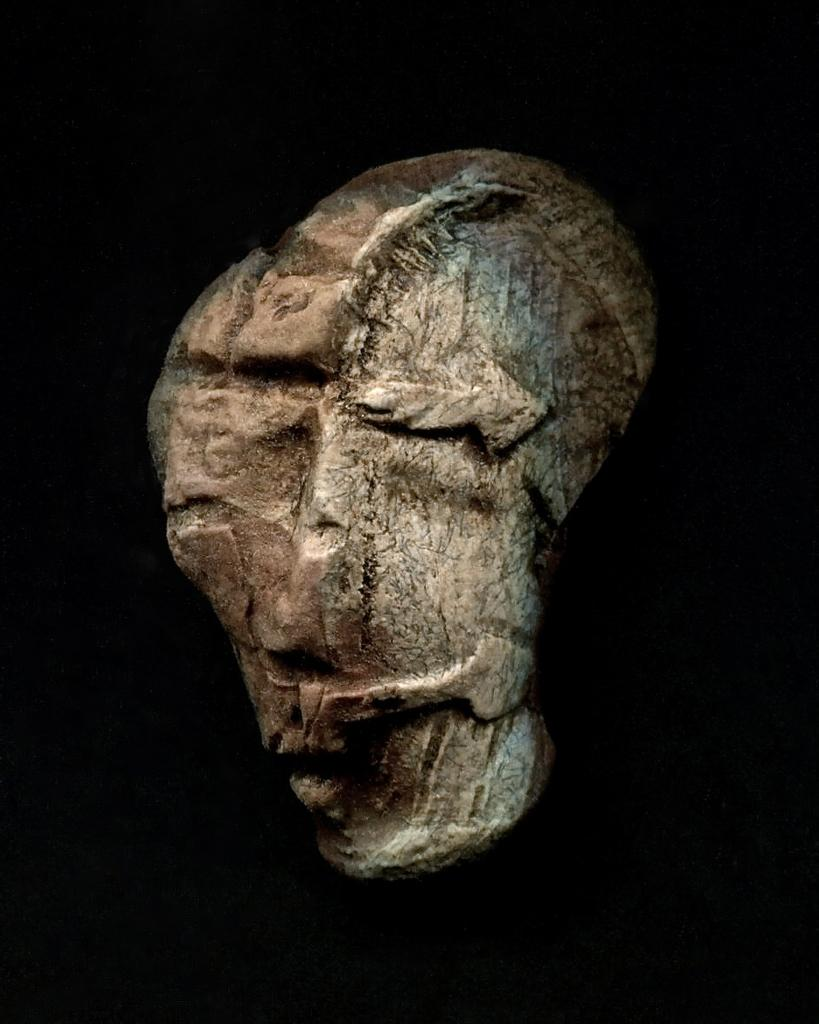What is the main subject of the image? There is an artifact in the center of the image. What color is the background of the image? The background of the image is black. Are there any fairies visible in the image? No, there are no fairies present in the image. What type of quiver can be seen in the image? There is no quiver present in the image. 